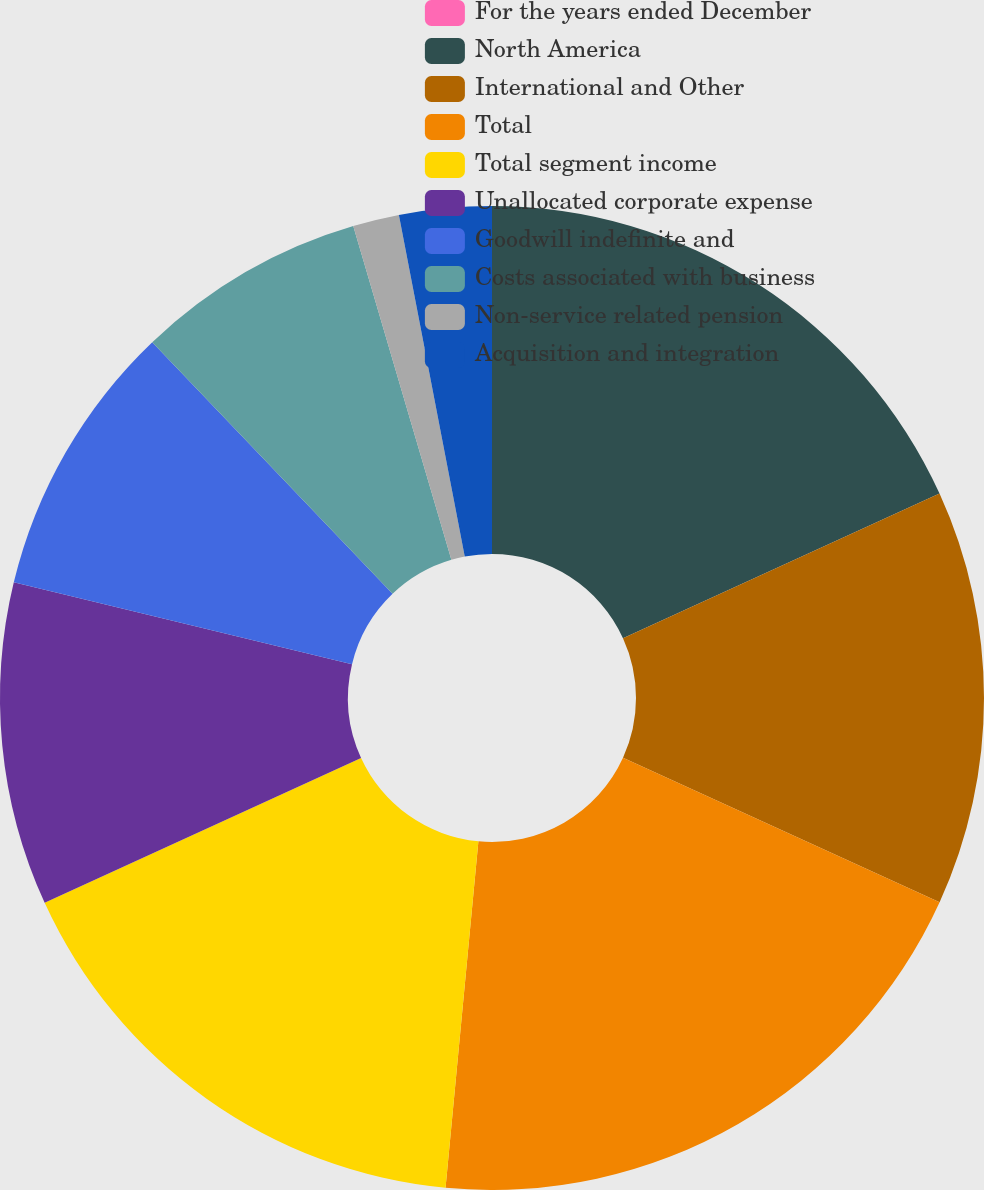<chart> <loc_0><loc_0><loc_500><loc_500><pie_chart><fcel>For the years ended December<fcel>North America<fcel>International and Other<fcel>Total<fcel>Total segment income<fcel>Unallocated corporate expense<fcel>Goodwill indefinite and<fcel>Costs associated with business<fcel>Non-service related pension<fcel>Acquisition and integration<nl><fcel>0.0%<fcel>18.18%<fcel>13.63%<fcel>19.69%<fcel>16.66%<fcel>10.61%<fcel>9.09%<fcel>7.58%<fcel>1.52%<fcel>3.03%<nl></chart> 